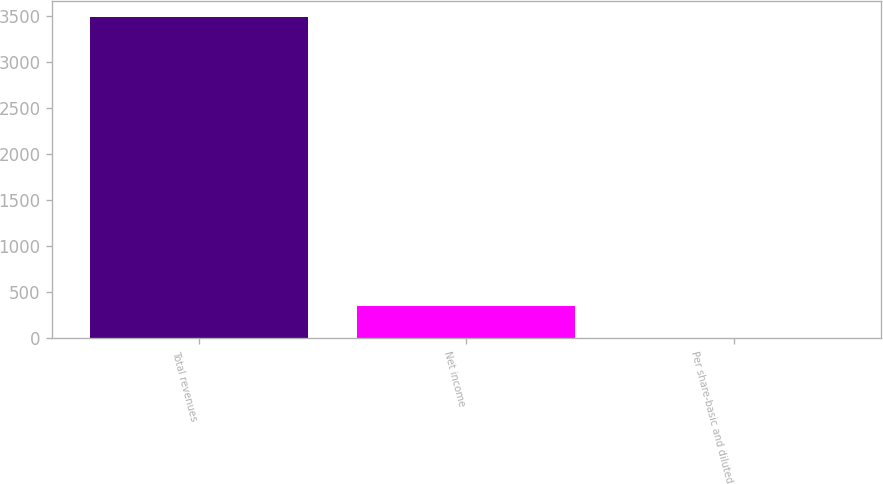<chart> <loc_0><loc_0><loc_500><loc_500><bar_chart><fcel>Total revenues<fcel>Net income<fcel>Per share-basic and diluted<nl><fcel>3493.3<fcel>349.38<fcel>0.06<nl></chart> 